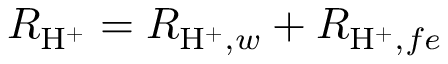Convert formula to latex. <formula><loc_0><loc_0><loc_500><loc_500>R _ { H ^ { + } } = R _ { H ^ { + } , w } + R _ { H ^ { + } , f e }</formula> 